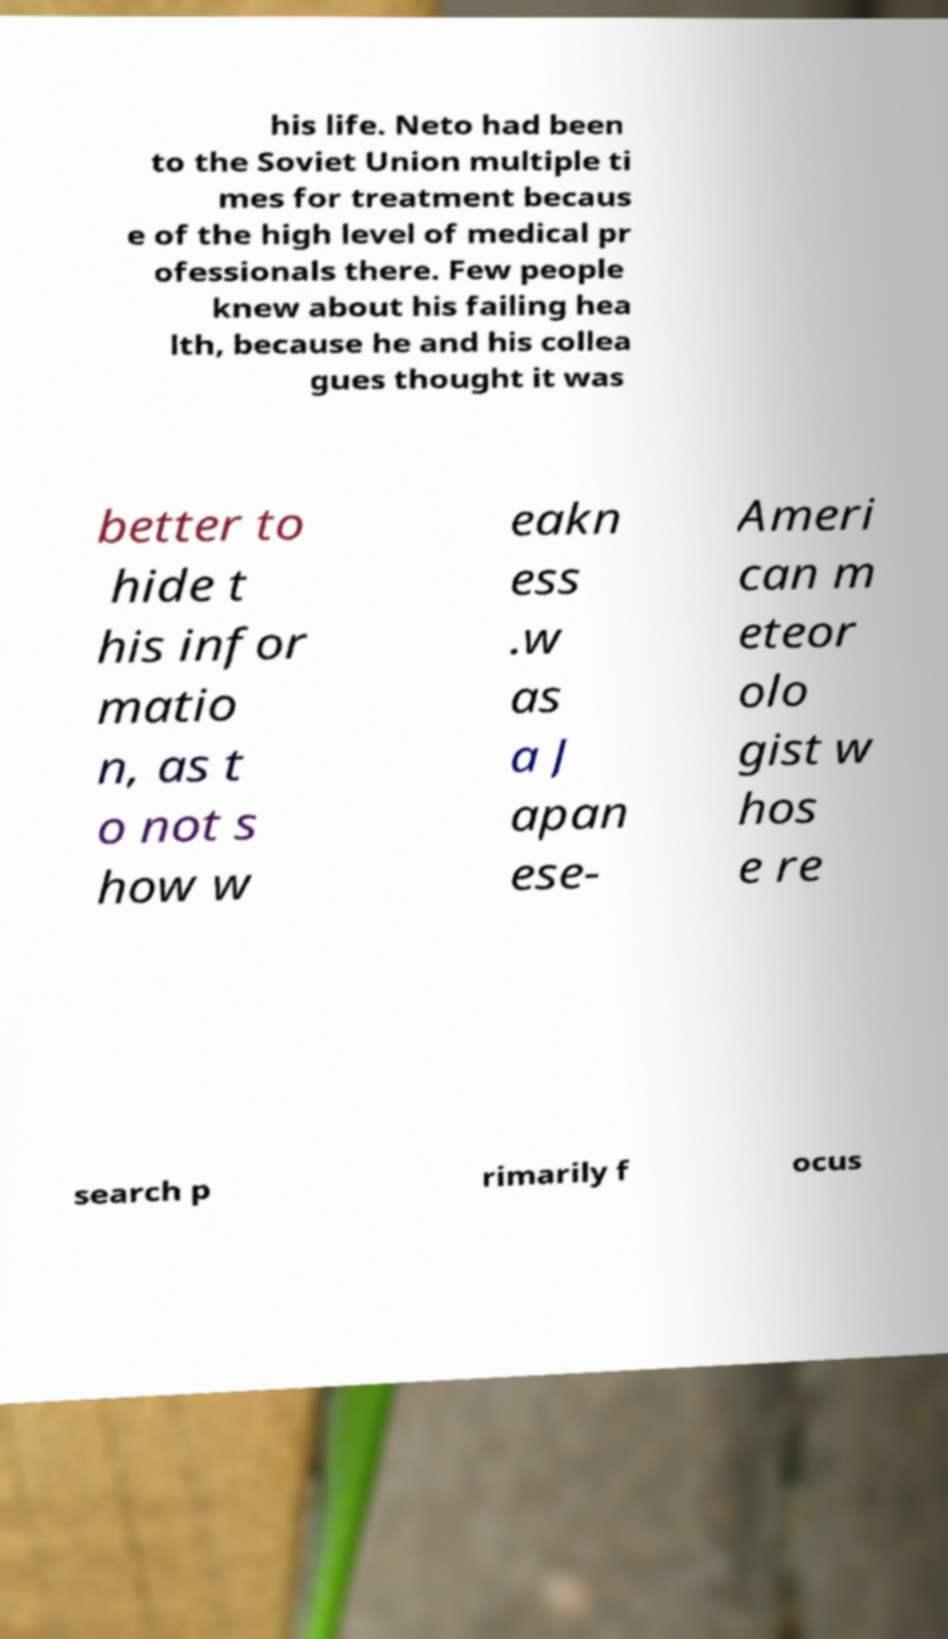Please identify and transcribe the text found in this image. his life. Neto had been to the Soviet Union multiple ti mes for treatment becaus e of the high level of medical pr ofessionals there. Few people knew about his failing hea lth, because he and his collea gues thought it was better to hide t his infor matio n, as t o not s how w eakn ess .w as a J apan ese- Ameri can m eteor olo gist w hos e re search p rimarily f ocus 